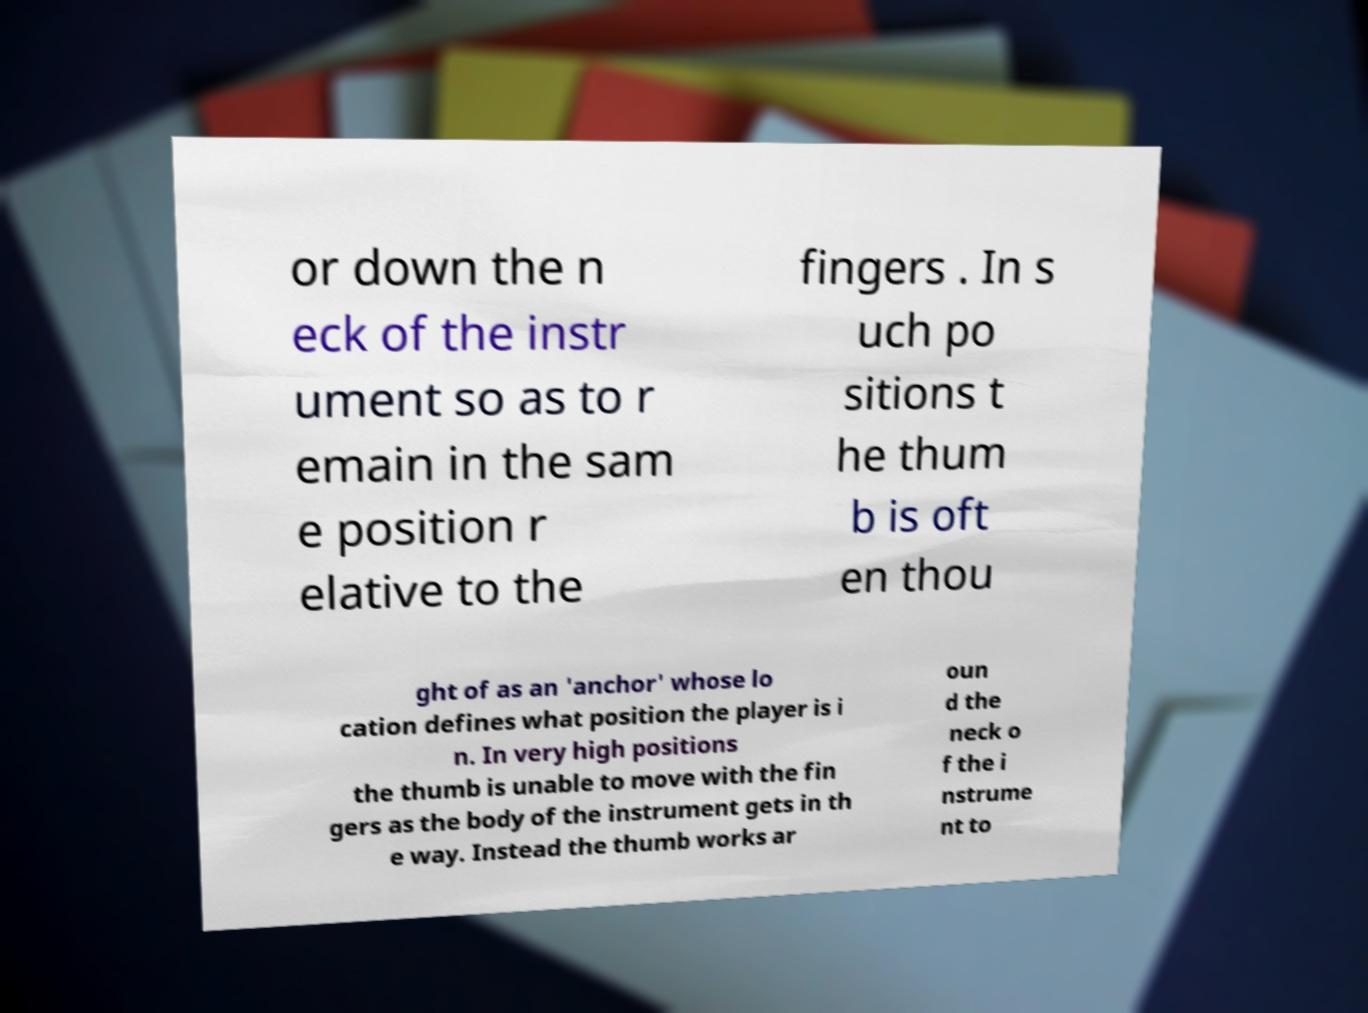I need the written content from this picture converted into text. Can you do that? or down the n eck of the instr ument so as to r emain in the sam e position r elative to the fingers . In s uch po sitions t he thum b is oft en thou ght of as an 'anchor' whose lo cation defines what position the player is i n. In very high positions the thumb is unable to move with the fin gers as the body of the instrument gets in th e way. Instead the thumb works ar oun d the neck o f the i nstrume nt to 